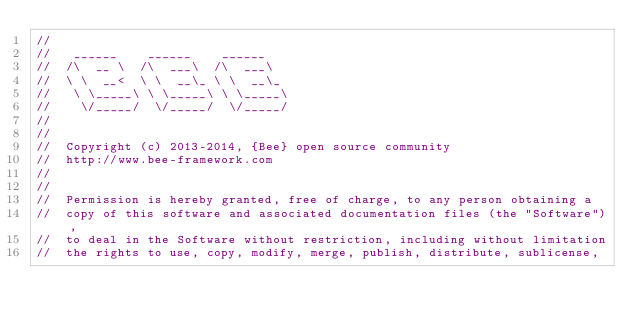<code> <loc_0><loc_0><loc_500><loc_500><_ObjectiveC_>//
//	 ______    ______    ______
//	/\  __ \  /\  ___\  /\  ___\
//	\ \  __<  \ \  __\_ \ \  __\_
//	 \ \_____\ \ \_____\ \ \_____\
//	  \/_____/  \/_____/  \/_____/
//
//
//	Copyright (c) 2013-2014, {Bee} open source community
//	http://www.bee-framework.com
//
//
//	Permission is hereby granted, free of charge, to any person obtaining a
//	copy of this software and associated documentation files (the "Software"),
//	to deal in the Software without restriction, including without limitation
//	the rights to use, copy, modify, merge, publish, distribute, sublicense,</code> 